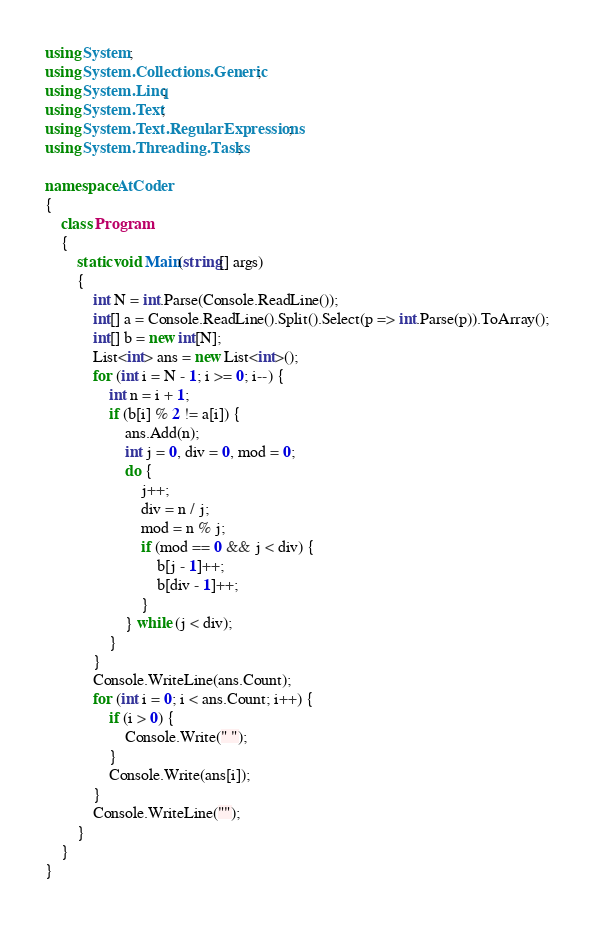Convert code to text. <code><loc_0><loc_0><loc_500><loc_500><_C#_>using System;
using System.Collections.Generic;
using System.Linq;
using System.Text;
using System.Text.RegularExpressions;
using System.Threading.Tasks;

namespace AtCoder
{
	class Program
	{
		static void Main(string[] args)
		{
			int N = int.Parse(Console.ReadLine());
			int[] a = Console.ReadLine().Split().Select(p => int.Parse(p)).ToArray();
			int[] b = new int[N];
			List<int> ans = new List<int>();
			for (int i = N - 1; i >= 0; i--) {
				int n = i + 1;
				if (b[i] % 2 != a[i]) {
					ans.Add(n);
					int j = 0, div = 0, mod = 0;
					do {
						j++;
						div = n / j;
						mod = n % j;
						if (mod == 0 && j < div) {
							b[j - 1]++;
							b[div - 1]++;
						}
					} while (j < div);
				}
			}
			Console.WriteLine(ans.Count);
			for (int i = 0; i < ans.Count; i++) {
				if (i > 0) {
					Console.Write(" ");
				}
				Console.Write(ans[i]);
			}
			Console.WriteLine("");
		}
	}
}
</code> 